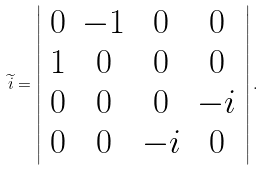Convert formula to latex. <formula><loc_0><loc_0><loc_500><loc_500>\widetilde { i } = \left | \begin{array} { c c c c } 0 & - 1 & 0 & 0 \\ 1 & 0 & 0 & 0 \\ 0 & 0 & 0 & - i \\ 0 & 0 & - i & 0 \end{array} \right | .</formula> 